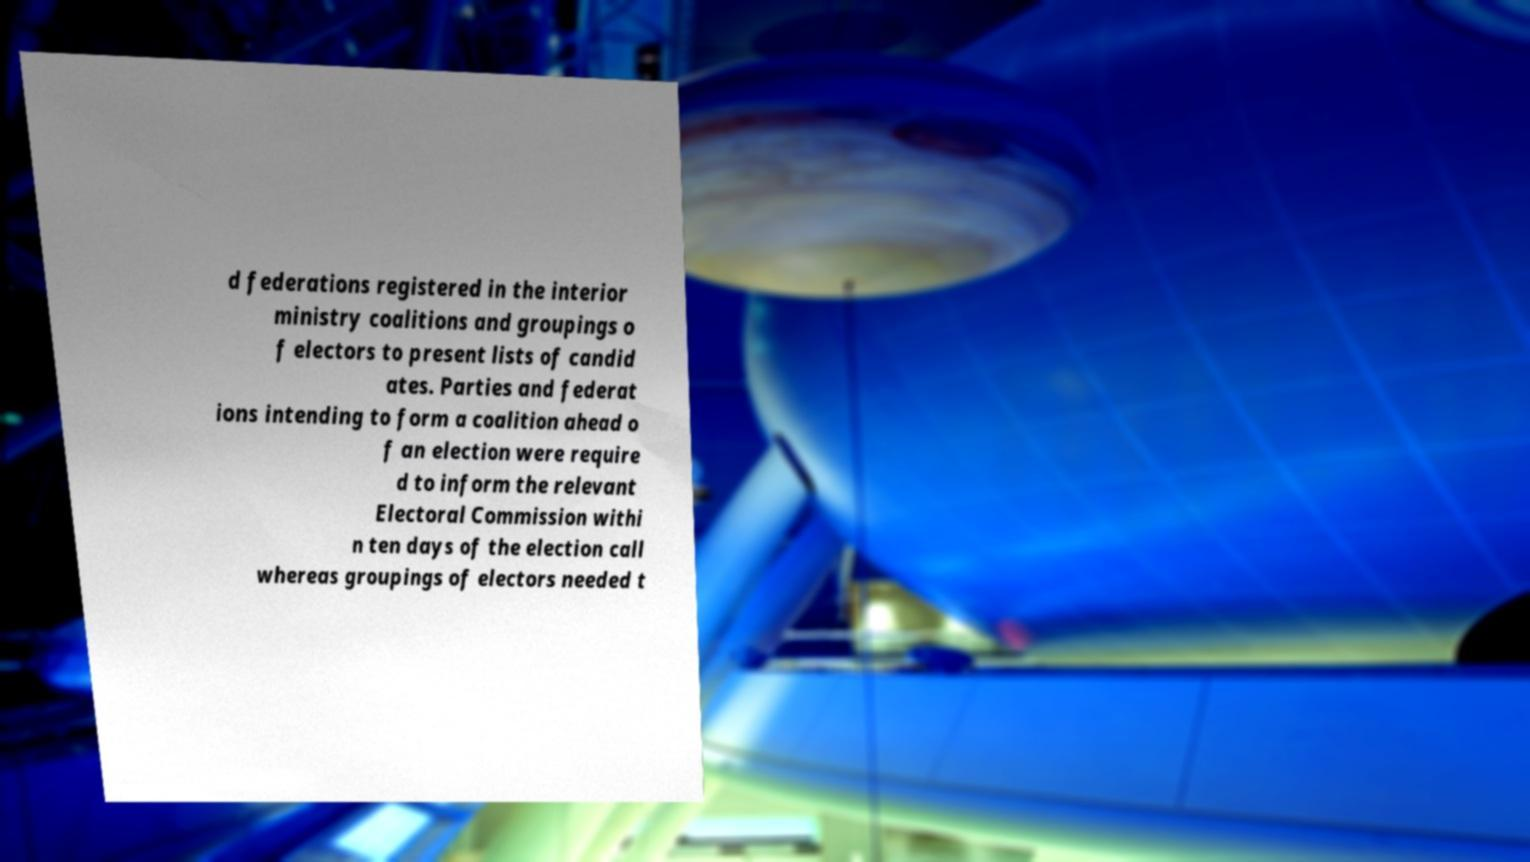Can you accurately transcribe the text from the provided image for me? d federations registered in the interior ministry coalitions and groupings o f electors to present lists of candid ates. Parties and federat ions intending to form a coalition ahead o f an election were require d to inform the relevant Electoral Commission withi n ten days of the election call whereas groupings of electors needed t 